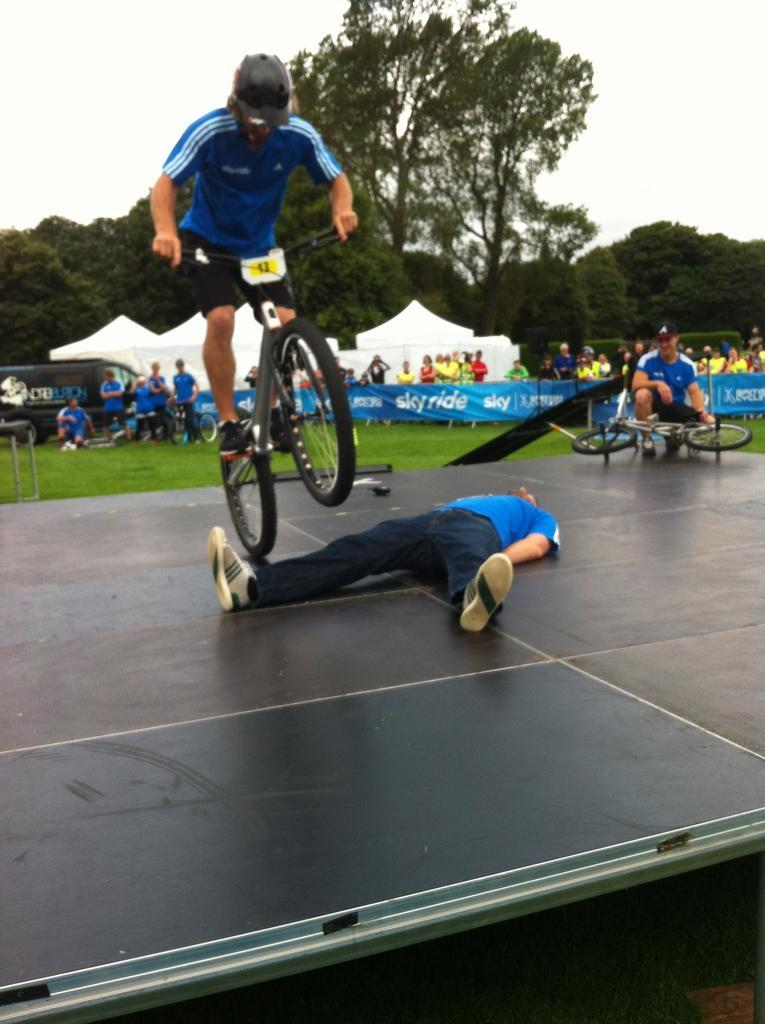Could you give a brief overview of what you see in this image? In this image, we can see three people are on the stage. Here a person is riding a bicycle. Right side of the image, a person is holding a wheel. Background we can see a grass, banners, group of people, tents, vehicle, so many trees. Top of the image, there is a sky. In the middle of the image, a person is lying on the stage. 